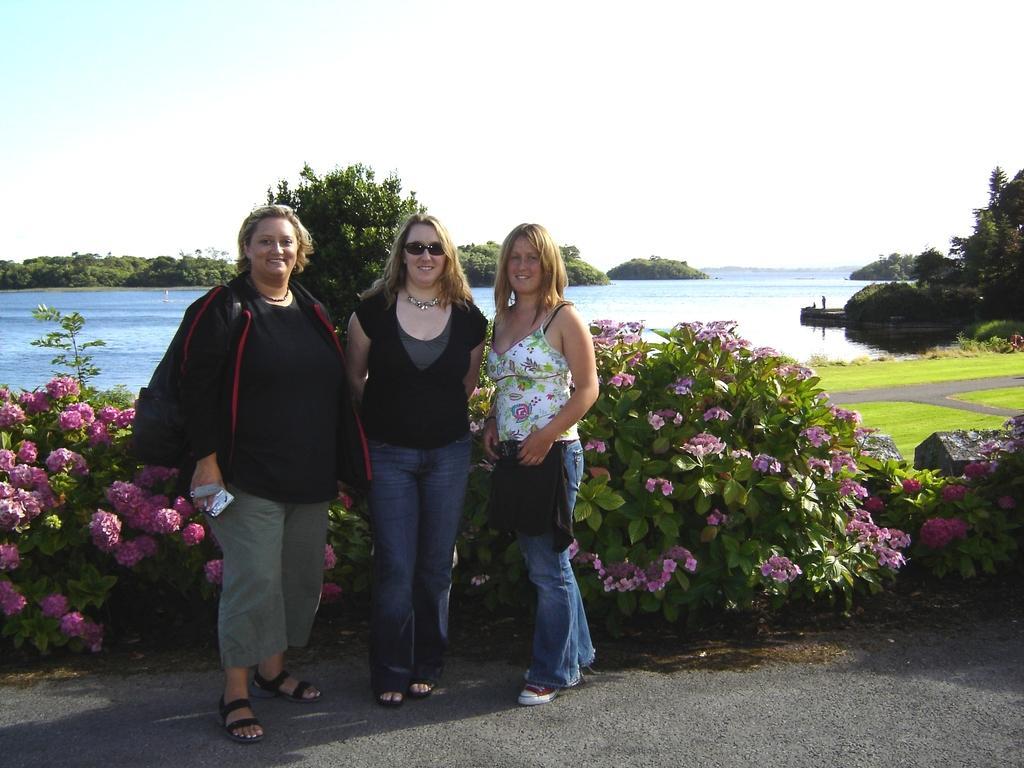Please provide a concise description of this image. In this image I can see a road in the front and on it I can see three women are standing. In the background I can see number of flowers, number of trees and water. I can also see grass ground on the right side and in the background I can see the sky. In the front I can see smile on their faces and I can see the left one is holding a white colour thing. 